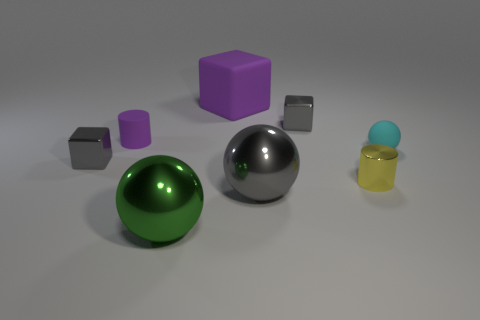Add 5 cyan rubber things. How many cyan rubber things exist? 6 Add 1 small metallic cubes. How many objects exist? 9 Subtract all green balls. How many balls are left? 2 Subtract all big spheres. How many spheres are left? 1 Subtract 0 red spheres. How many objects are left? 8 Subtract all blocks. How many objects are left? 5 Subtract 3 balls. How many balls are left? 0 Subtract all cyan cylinders. Subtract all brown balls. How many cylinders are left? 2 Subtract all yellow balls. How many purple blocks are left? 1 Subtract all small metal cylinders. Subtract all purple cylinders. How many objects are left? 6 